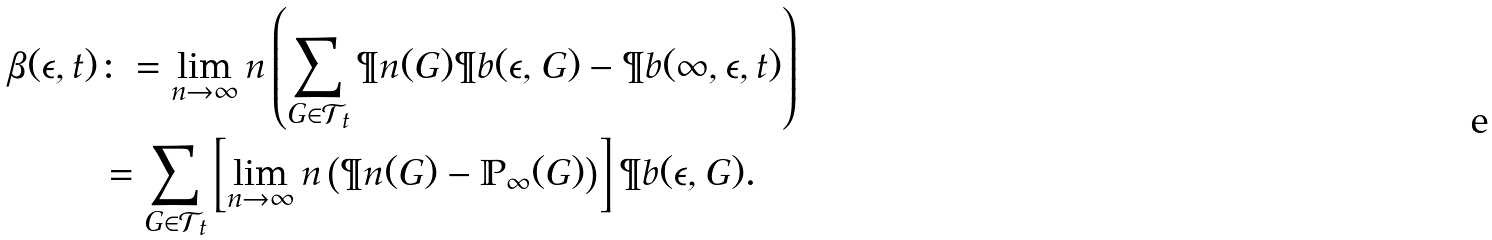<formula> <loc_0><loc_0><loc_500><loc_500>\beta ( \epsilon , t ) & \colon = \lim _ { n \to \infty } n \left ( \sum _ { G \in \mathcal { T } _ { t } } \P n ( G ) \P b ( \epsilon , G ) - \P b ( \infty , \epsilon , t ) \right ) \\ & = \sum _ { G \in \mathcal { T } _ { t } } \left [ \lim _ { n \to \infty } n \left ( \P n ( G ) - \mathbb { P } _ { \infty } ( G ) \right ) \right ] \P b ( \epsilon , G ) \text {.}</formula> 